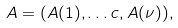Convert formula to latex. <formula><loc_0><loc_0><loc_500><loc_500>A = ( A ( 1 ) , \dots c , A ( \nu ) ) ,</formula> 